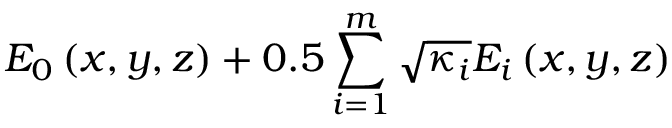Convert formula to latex. <formula><loc_0><loc_0><loc_500><loc_500>E _ { 0 } \left ( x , y , z \right ) + 0 . 5 \sum _ { i = 1 } ^ { m } \sqrt { \kappa _ { i } } E _ { i } \left ( x , y , z \right )</formula> 